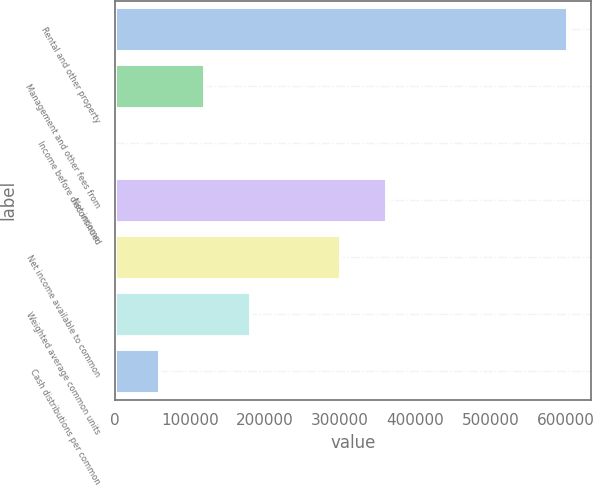<chart> <loc_0><loc_0><loc_500><loc_500><bar_chart><fcel>Rental and other property<fcel>Management and other fees from<fcel>Income before discontinued<fcel>Net income<fcel>Net income available to common<fcel>Weighted average common units<fcel>Cash distributions per common<nl><fcel>603327<fcel>120668<fcel>3.27<fcel>361997<fcel>301665<fcel>181000<fcel>60335.6<nl></chart> 